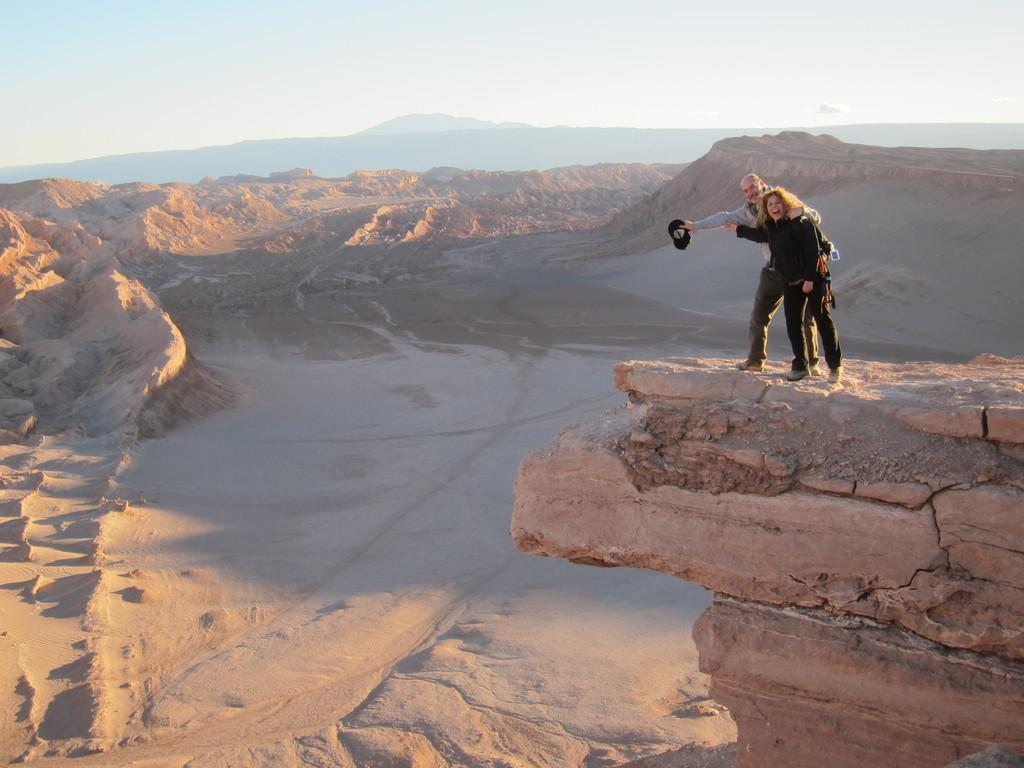Who are the people standing on the rock in the image? There are two people standing on a rock on the right side of the image. What can be seen in the background of the image? There are rocks, hills, and the sky visible in the background of the image. What is the terrain like at the bottom of the image? There is sand at the bottom of the image. Reasoning: Let's think step by identifying the main subjects and objects in the image based on the provided facts. We then formulate questions that focus on the location and characteristics of these subjects and objects, ensuring that each question can be answered definitively with the information given. We avoid yes/no questions and ensure that the language is simple and clear. Absurd Question/Answer: What do the girls regret in the image? There are no girls present in the image, so it is not possible to determine what they might regret. What view can be seen from the top of the rock in the image? There is no specific view mentioned in the image, but it does show rocks, hills, and the sky in the background. --- Facts: 1. There is a car in the image. 2. The car is parked on the street. 3. There are trees on the left side of the image. 4. There is a sidewalk in the image. 5. There are people walking on the sidewalk. Absurd Topics: dance, ocean, dinosaur Conversation: What type of vehicle is in the image? There is a car in the image. Where is the car located in the image? The car is parked on the street. What can be seen on the left side of the image? There are trees on the left side of the image. What type of path is present in the image? There is a sidewalk in the image. What are the people on the sidewalk doing? There are people walking on the sidewalk. Reasoning: Let's think step by step in order to produce the conversation. We start by identifying the main subject in the image, which is the car. Then, we expand the conversation to include other items that are also visible, such as the street, trees, sidewalk, 